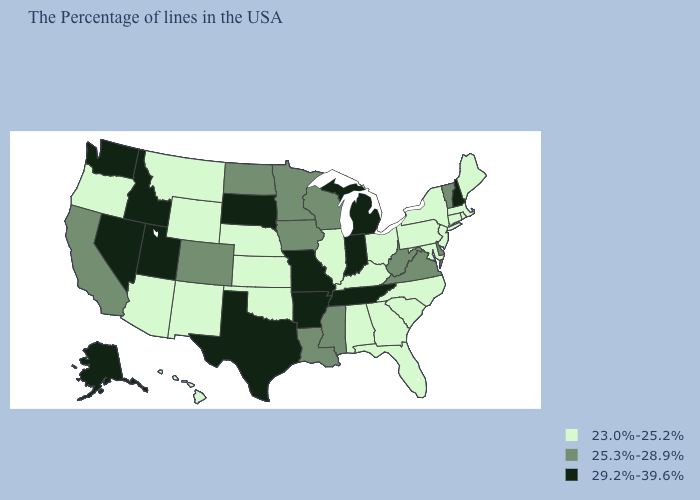What is the value of Wyoming?
Be succinct. 23.0%-25.2%. Does the map have missing data?
Answer briefly. No. Does Hawaii have the lowest value in the USA?
Quick response, please. Yes. Is the legend a continuous bar?
Answer briefly. No. What is the lowest value in the South?
Keep it brief. 23.0%-25.2%. What is the highest value in the USA?
Quick response, please. 29.2%-39.6%. Does the map have missing data?
Keep it brief. No. What is the value of California?
Answer briefly. 25.3%-28.9%. What is the lowest value in the West?
Quick response, please. 23.0%-25.2%. How many symbols are there in the legend?
Give a very brief answer. 3. Does Oklahoma have a lower value than Alaska?
Give a very brief answer. Yes. Does Minnesota have a higher value than Mississippi?
Concise answer only. No. Name the states that have a value in the range 29.2%-39.6%?
Answer briefly. New Hampshire, Michigan, Indiana, Tennessee, Missouri, Arkansas, Texas, South Dakota, Utah, Idaho, Nevada, Washington, Alaska. What is the value of Arkansas?
Quick response, please. 29.2%-39.6%. Does the map have missing data?
Concise answer only. No. 